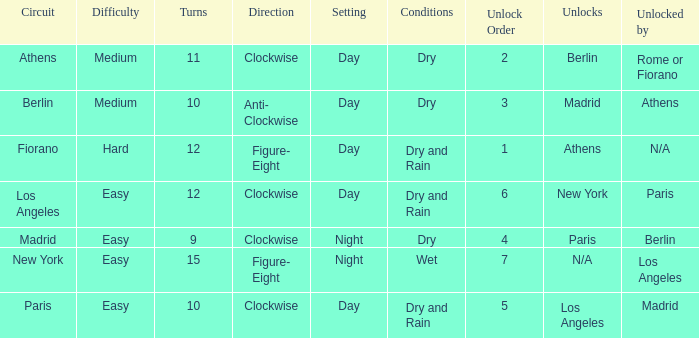What is the minimum unlock sequence for the athens circuit? 2.0. 